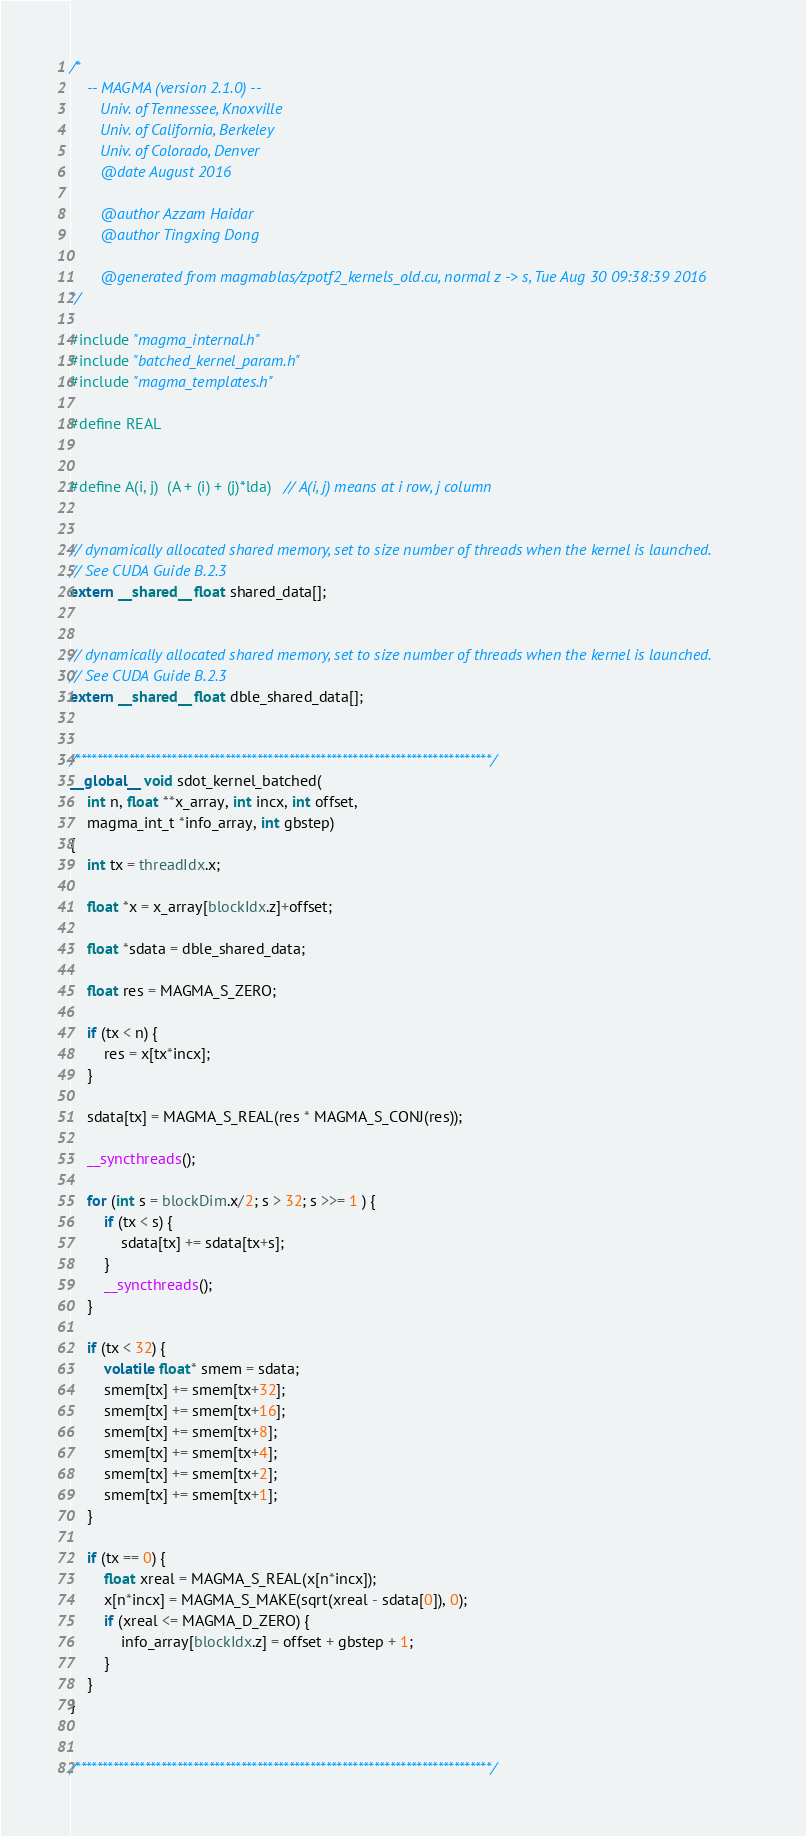Convert code to text. <code><loc_0><loc_0><loc_500><loc_500><_Cuda_>/*
    -- MAGMA (version 2.1.0) --
       Univ. of Tennessee, Knoxville
       Univ. of California, Berkeley
       Univ. of Colorado, Denver
       @date August 2016
       
       @author Azzam Haidar
       @author Tingxing Dong

       @generated from magmablas/zpotf2_kernels_old.cu, normal z -> s, Tue Aug 30 09:38:39 2016
*/

#include "magma_internal.h"
#include "batched_kernel_param.h"
#include "magma_templates.h"

#define REAL


#define A(i, j)  (A + (i) + (j)*lda)   // A(i, j) means at i row, j column


// dynamically allocated shared memory, set to size number of threads when the kernel is launched.
// See CUDA Guide B.2.3
extern __shared__ float shared_data[];


// dynamically allocated shared memory, set to size number of threads when the kernel is launched.
// See CUDA Guide B.2.3
extern __shared__ float dble_shared_data[];


/******************************************************************************/
__global__ void sdot_kernel_batched(
    int n, float **x_array, int incx, int offset,
    magma_int_t *info_array, int gbstep)
{
    int tx = threadIdx.x;

    float *x = x_array[blockIdx.z]+offset;

    float *sdata = dble_shared_data;

    float res = MAGMA_S_ZERO;

    if (tx < n) {
        res = x[tx*incx];
    }

    sdata[tx] = MAGMA_S_REAL(res * MAGMA_S_CONJ(res));

    __syncthreads();

    for (int s = blockDim.x/2; s > 32; s >>= 1 ) {
        if (tx < s) {
            sdata[tx] += sdata[tx+s];
        }
        __syncthreads();
    }

    if (tx < 32) {
        volatile float* smem = sdata;
        smem[tx] += smem[tx+32];
        smem[tx] += smem[tx+16];
        smem[tx] += smem[tx+8];
        smem[tx] += smem[tx+4];
        smem[tx] += smem[tx+2];
        smem[tx] += smem[tx+1];
    }

    if (tx == 0) {
        float xreal = MAGMA_S_REAL(x[n*incx]);        
        x[n*incx] = MAGMA_S_MAKE(sqrt(xreal - sdata[0]), 0);
        if (xreal <= MAGMA_D_ZERO) {
            info_array[blockIdx.z] = offset + gbstep + 1;
        }
    }
}


/******************************************************************************/</code> 